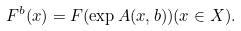<formula> <loc_0><loc_0><loc_500><loc_500>F ^ { b } ( x ) = F ( \exp A ( x , b ) ) ( x \in X ) .</formula> 